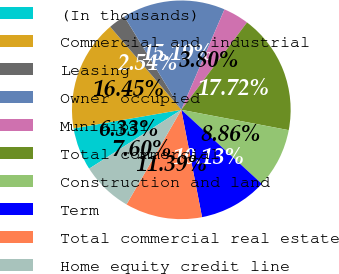Convert chart to OTSL. <chart><loc_0><loc_0><loc_500><loc_500><pie_chart><fcel>(In thousands)<fcel>Commercial and industrial<fcel>Leasing<fcel>Owner occupied<fcel>Municipal<fcel>Total commercial<fcel>Construction and land<fcel>Term<fcel>Total commercial real estate<fcel>Home equity credit line<nl><fcel>6.33%<fcel>16.45%<fcel>2.54%<fcel>15.19%<fcel>3.8%<fcel>17.72%<fcel>8.86%<fcel>10.13%<fcel>11.39%<fcel>7.6%<nl></chart> 